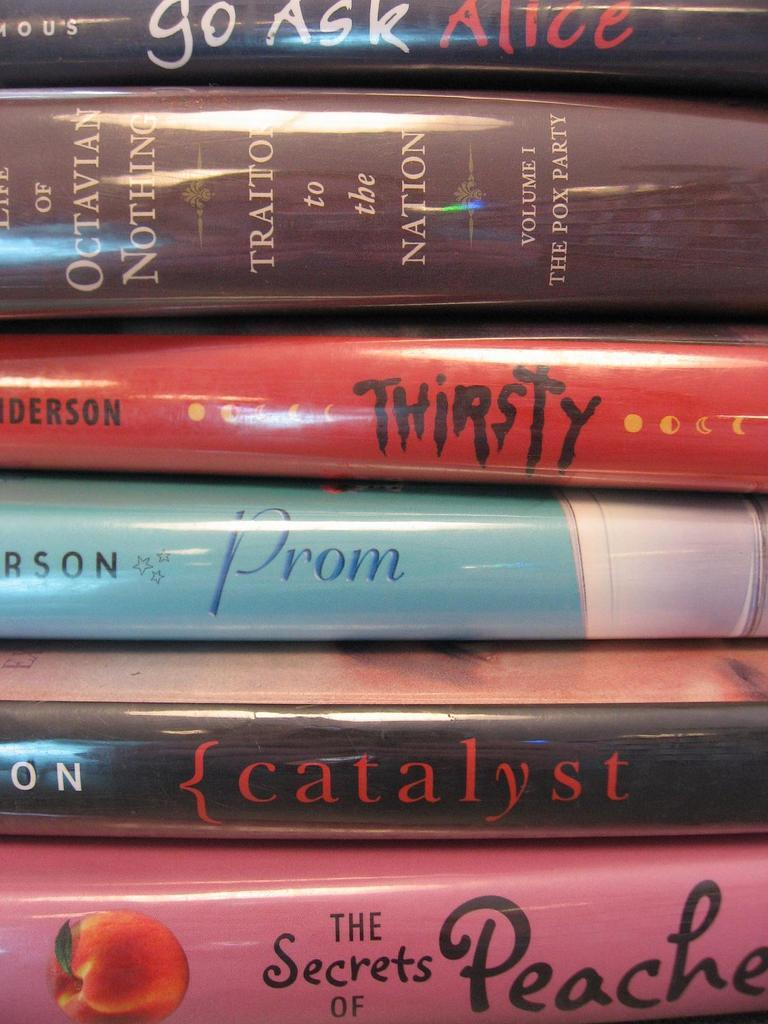Provide a one-sentence caption for the provided image. a stack of several books including Prom, Thirsty, and {Catalyst. 